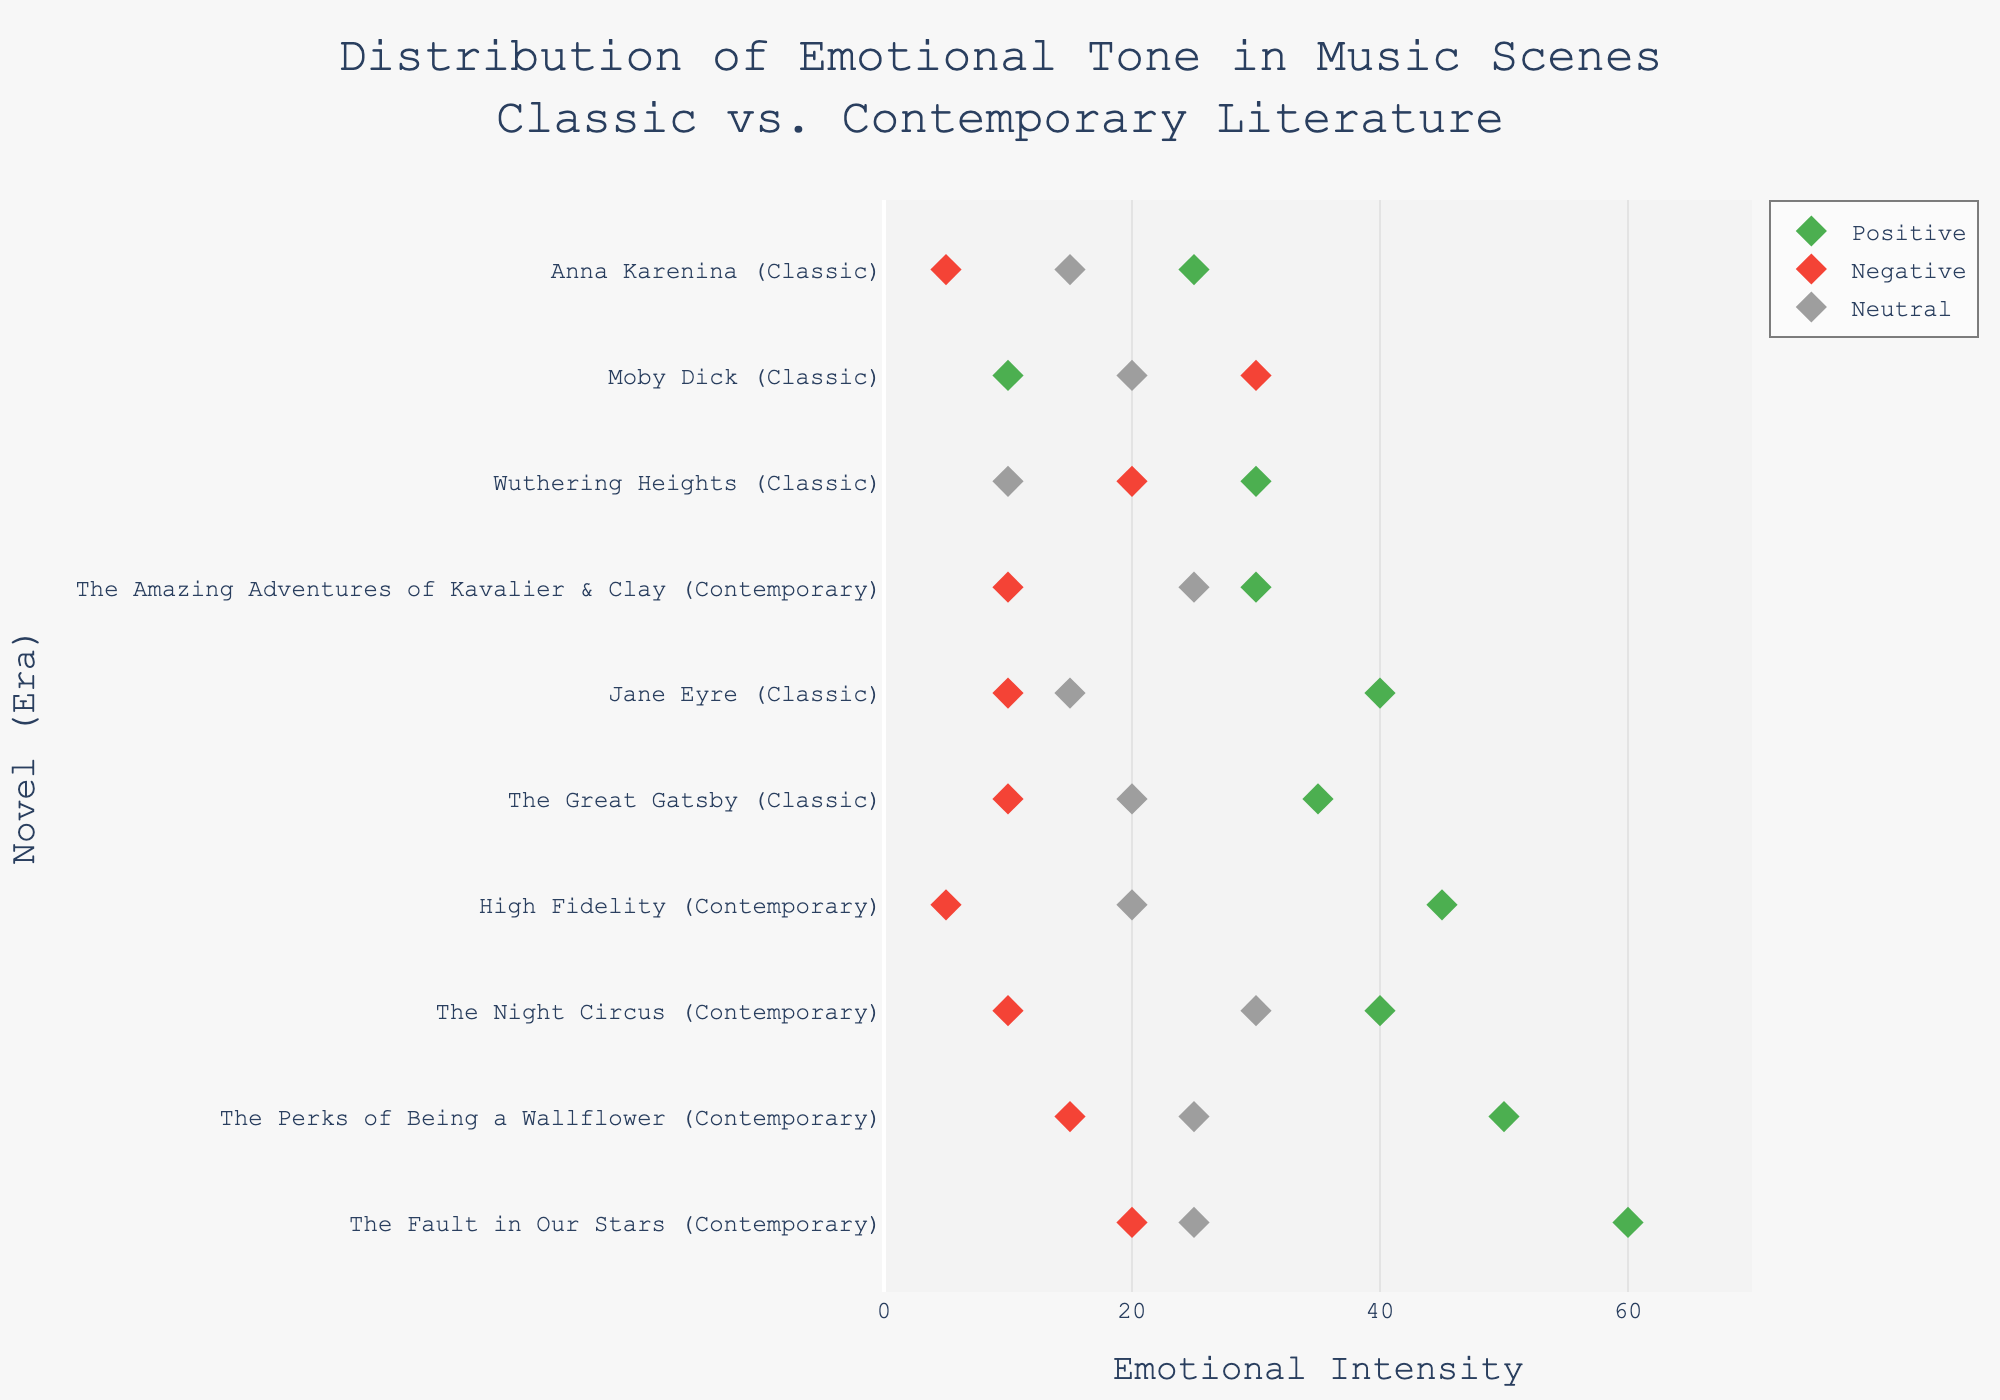What is the title of the figure? The title of the figure is prominently displayed at the top. It reads "Distribution of Emotional Tone in Music Scenes Classic vs. Contemporary Literature."
Answer: Distribution of Emotional Tone in Music Scenes Classic vs. Contemporary Literature How many novels from the contemporary era are depicted in the figure? The figure shows novels from both classic and contemporary eras mentioned on the vertical axis (y-axis). Count the number of contemporary ones by checking the labels in parentheses.
Answer: 5 Which music scene has the highest positive emotional tone? Look along the x-axis labeled 'Emotional Intensity' and identify the dot farthest to the right for the positive emotion (typically marked in green). From there, trace back to the corresponding novel on the y-axis.
Answer: Augustus and Hazel's Most Beautiful Song (The Fault in Our Stars) Are there more positive emotions conveyed in contemporary or classic novels? Compare the overall positions and number of positive emotion dots (marked in green) across contemporary and classic categories on the y-axis.
Answer: Contemporary What is the range of neutral emotions in classic literature scenes? Identify the dots for neutral emotions (marked in grey) for classic novels and note the minimum and maximum values along the x-axis.
Answer: 10 to 20 Which contemporary novel has the lowest negative emotional tone? Check the positions of the negative emotion dots (marked in red) for contemporary novels and identify the one closest to the origin on the x-axis.
Answer: Rob's Record Store Monologue (High Fidelity) What is the combined emotional intensity (sum of positive, negative, and neutral) of Jane's Piano Performance at Thornfield scene? Add the values corresponding to positive, negative, and neutral emotions for the specified scene. The values are given as D 40, F 10, and C 15. Sum them up: 40 + 10 + 15 = 65.
Answer: 65 Which novel scene shows equal positive and neutral emotional tones? Look for dots plotting to the same x-axis value for both the positive and neutral emotions (green and grey dots) and verify their corresponding novel.
Answer: Joe and Sam's Creation of "The Escapist" (The Amazing Adventures of Kavalier & Clay) What is the median value of the negative emotional tone for contemporary novels? List the negative emotion values for contemporary novels: 15, 5, 10, 10, 20. Arrange these: 5, 10, 10, 15, 20. The median is the middle value, which is 10.
Answer: 10 Which music scene in classic novels displayed the highest variability in emotional tones? For classic novels, compare the range of values between the highest and lowest points among the positive, negative, and neutral dots. The wider the spread, the higher the variability.
Answer: Catherine and Heathcliff's Childhood Tunes (Wuthering Heights) 